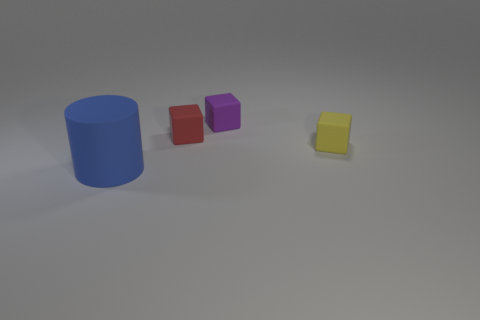Add 4 tiny red rubber blocks. How many tiny red rubber blocks exist? 5 Add 3 small gray matte blocks. How many objects exist? 7 Subtract all yellow cubes. How many cubes are left? 2 Subtract 0 cyan balls. How many objects are left? 4 Subtract all cylinders. How many objects are left? 3 Subtract 1 cylinders. How many cylinders are left? 0 Subtract all red blocks. Subtract all blue spheres. How many blocks are left? 2 Subtract all brown cylinders. How many blue cubes are left? 0 Subtract all large red shiny things. Subtract all yellow things. How many objects are left? 3 Add 2 tiny purple blocks. How many tiny purple blocks are left? 3 